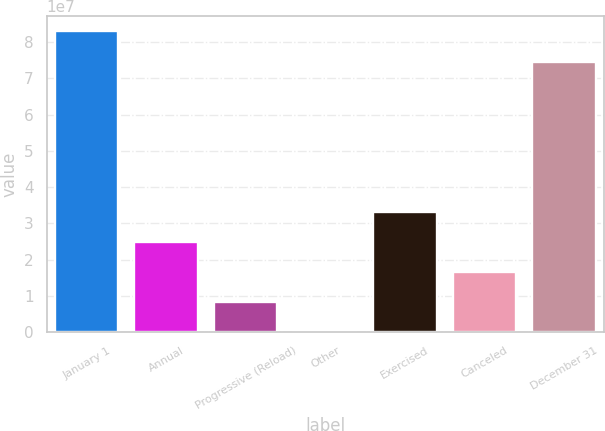Convert chart to OTSL. <chart><loc_0><loc_0><loc_500><loc_500><bar_chart><fcel>January 1<fcel>Annual<fcel>Progressive (Reload)<fcel>Other<fcel>Exercised<fcel>Canceled<fcel>December 31<nl><fcel>8.28947e+07<fcel>2.48966e+07<fcel>8.33335e+06<fcel>51730<fcel>3.31782e+07<fcel>1.6615e+07<fcel>7.46131e+07<nl></chart> 